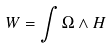<formula> <loc_0><loc_0><loc_500><loc_500>W = \int \Omega \wedge H</formula> 